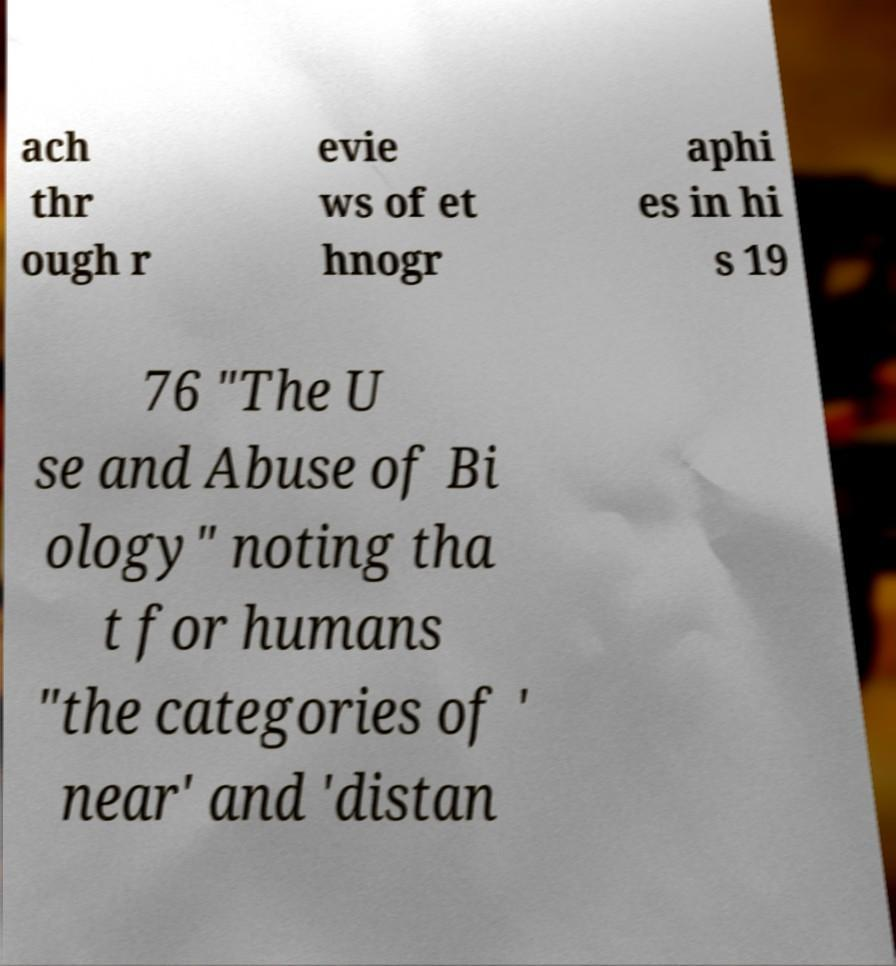What messages or text are displayed in this image? I need them in a readable, typed format. ach thr ough r evie ws of et hnogr aphi es in hi s 19 76 "The U se and Abuse of Bi ology" noting tha t for humans "the categories of ' near' and 'distan 